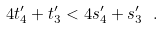Convert formula to latex. <formula><loc_0><loc_0><loc_500><loc_500>4 t _ { 4 } ^ { \prime } + t _ { 3 } ^ { \prime } < 4 s _ { 4 } ^ { \prime } + s _ { 3 } ^ { \prime } \ .</formula> 